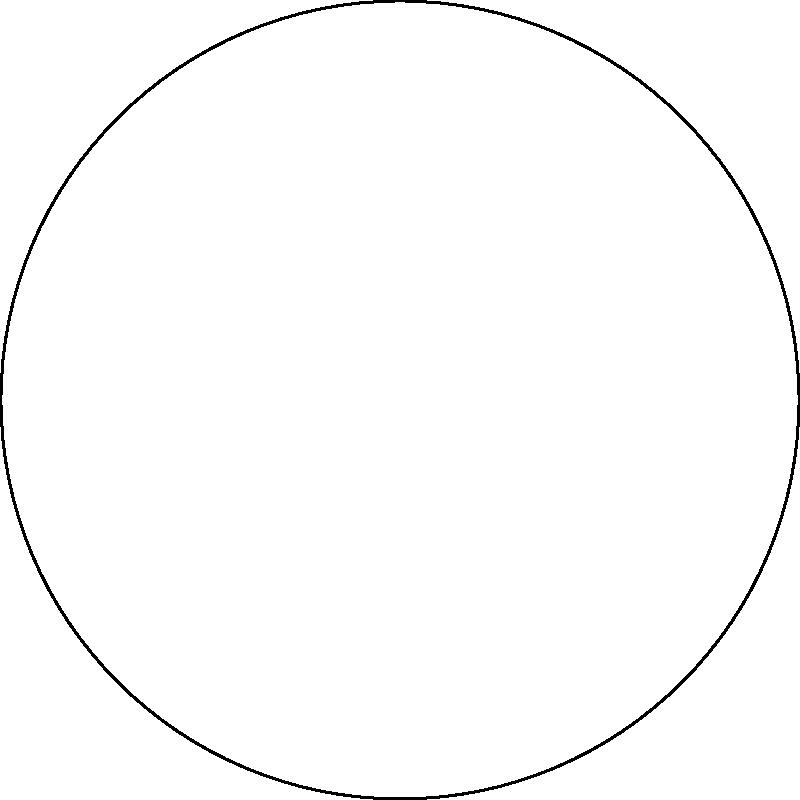In the Poincaré disk model of hyperbolic geometry shown above, three geodesics form a triangle ABC. Which of the following statements is true about the sum of the interior angles of this hyperbolic triangle? To understand this concept, let's follow these steps:

1. Recall that in Euclidean geometry, the sum of interior angles of a triangle is always 180°.

2. In hyperbolic geometry, visualized using the Poincaré disk model:
   a) Geodesics (straight lines) are represented by arcs of circles that intersect the boundary circle perpendicularly.
   b) The boundary circle represents points at infinity.

3. A key property of hyperbolic geometry is that the sum of interior angles of a triangle is always less than 180°.

4. This is because:
   a) Parallel lines in hyperbolic space diverge from each other.
   b) This causes the angles in a hyperbolic triangle to be "smaller" than their Euclidean counterparts.

5. The larger the hyperbolic triangle (i.e., the closer its vertices are to the boundary circle), the smaller the sum of its interior angles.

6. In the extreme case, as the vertices approach the boundary circle, the sum of the interior angles approaches 0°.

7. In the given diagram, we can see that the triangle ABC is relatively large within the Poincaré disk, suggesting that its interior angle sum will be significantly less than 180°.

Therefore, in hyperbolic geometry, as represented by the Poincaré disk model, the sum of the interior angles of triangle ABC is less than 180°.
Answer: Less than 180° 